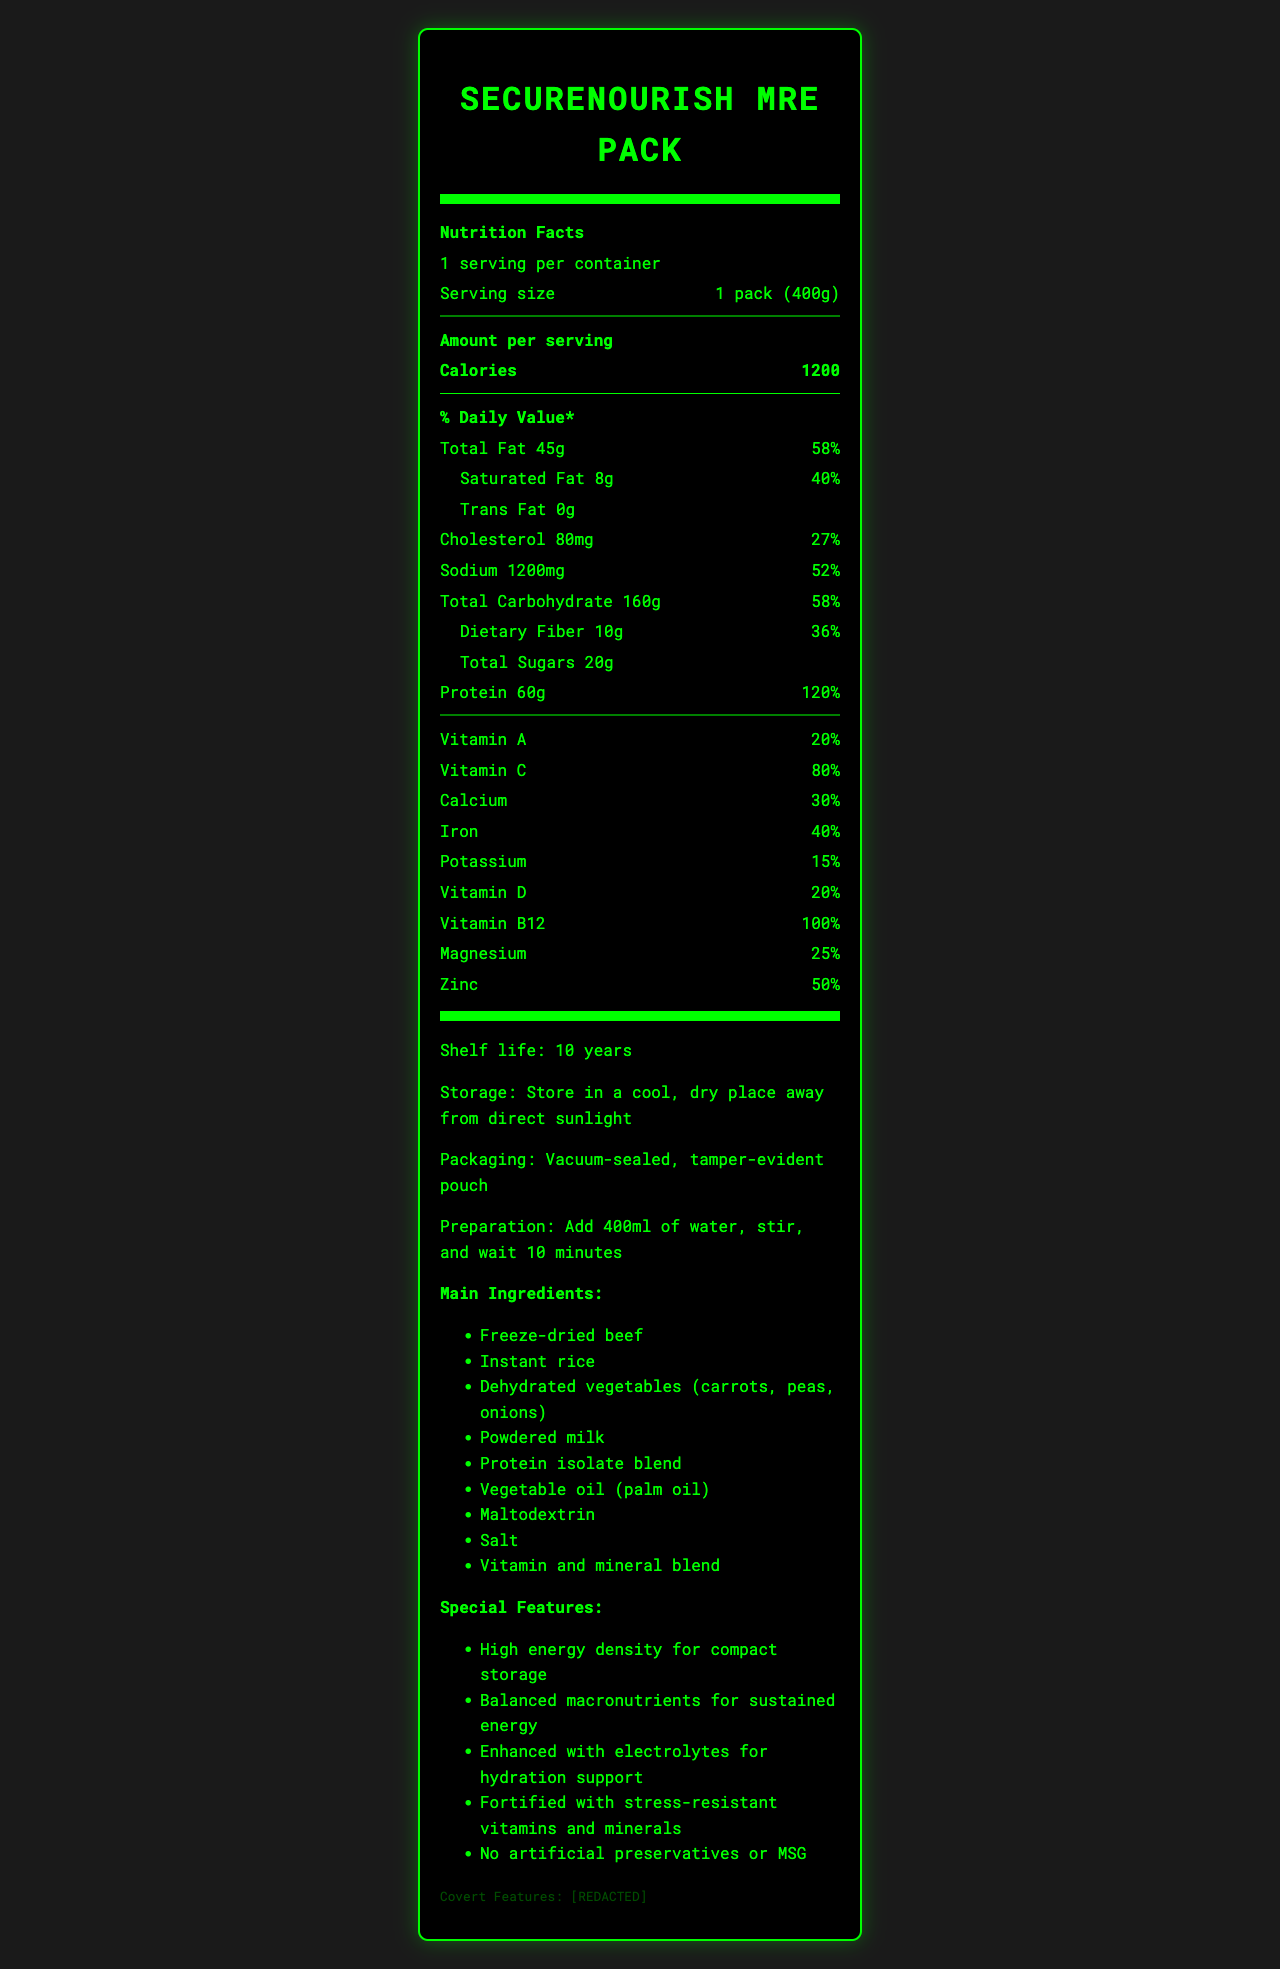what is the serving size of SecureNourish MRE Pack? The serving size is clearly stated as "1 pack (400g)" in the document.
Answer: 1 pack (400g) how many calories are in one serving? The document mentions that each serving contains 1200 calories.
Answer: 1200 what is the amount of total carbohydrates per serving? The label lists "Total Carbohydrate" as 160g per serving.
Answer: 160g which ingredient provides protein in the SecureNourish MRE Pack? The "Main Ingredients" section lists "Protein isolate blend" as one of the sources of protein.
Answer: Protein isolate blend how long is the shelf life of the product? The shelf life is noted as "10 years" in the document.
Answer: 10 years what percentage of the daily value of vitamin C does one serving provide? The document lists vitamin C as providing "80%" of the daily value.
Answer: 80% how much sodium is in one serving? The document specifies that one serving contains "Sodium 1200mg".
Answer: 1200mg what is the preparation instruction for the product? The preparation section clearly states the instructions as "Add 400ml of water, stir, and wait 10 minutes".
Answer: Add 400ml of water, stir, and wait 10 minutes which of the following nutrients has the highest daily value percentage? A. Iron B. Protein C. Magnesium D. Calcium The document lists Protein with a daily value of 120%, which is the highest among the options.
Answer: Protein what special feature helps with hydration support? A. Tamper-evident pouch B. Freeze-dried beef C. Enhanced with electrolytes D. No artificial preservatives The special feature "Enhanced with electrolytes for hydration support" is mentioned in the document.
Answer: C. Enhanced with electrolytes is there any trans fat in the SecureNourish MRE Pack? The label indicates "Trans Fat 0g", meaning there is no trans fat in the product.
Answer: No summarize the document. The summary gives an overview of the nutritional details, shelf life, preparation methods, special features, and covert attributes of the SecureNourish MRE Pack.
Answer: The document provides detailed nutritional information for the SecureNourish MRE Pack, a long-shelf-life emergency food supply. It includes information about serving size, calories, macronutrient amounts, and daily values for various vitamins and minerals. The product features a 10-year shelf life, specific preparation instructions, and special features like high energy density and stress-resistant vitamins. It also contains covert features for authenticity verification. what is the production lot number format? The document does not provide information regarding the format of the production lot number.
Answer: Cannot be determined 